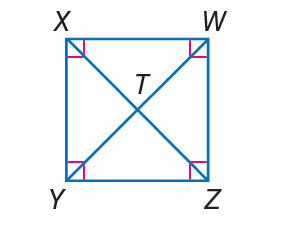Answer the mathemtical geometry problem and directly provide the correct option letter.
Question: W X Y Z is a square. If W T = 3, find m \angle W T Z.
Choices: A: 15 B: 30 C: 45 D: 90 D 